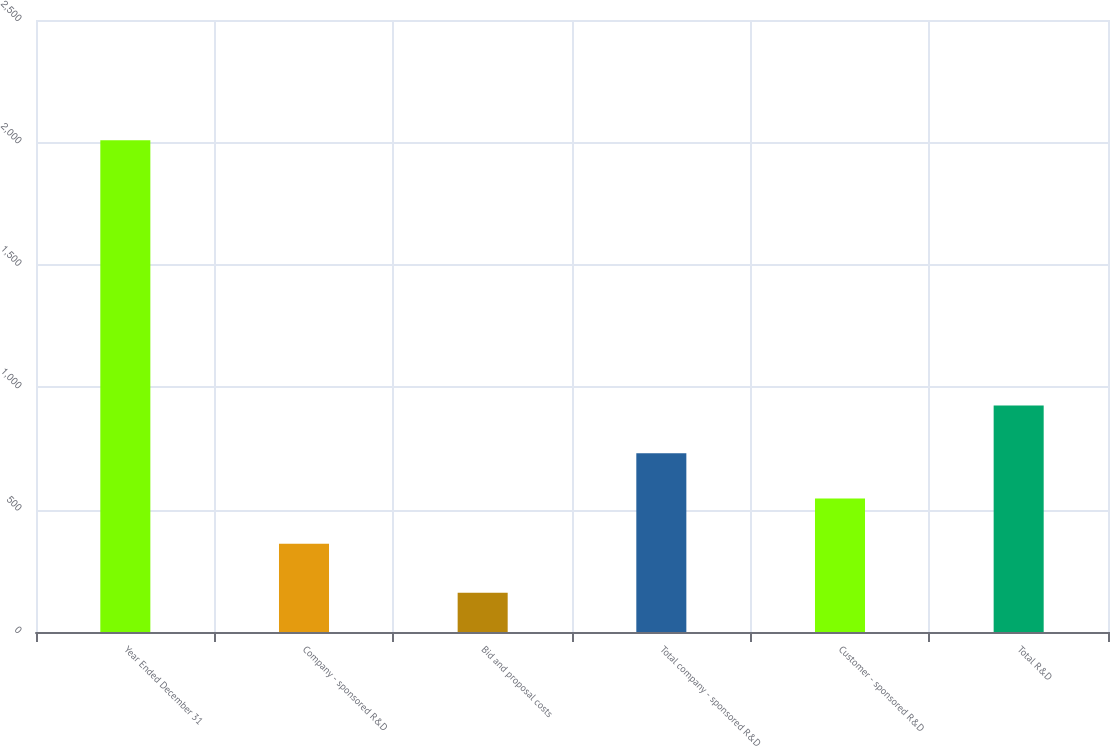Convert chart. <chart><loc_0><loc_0><loc_500><loc_500><bar_chart><fcel>Year Ended December 31<fcel>Company - sponsored R&D<fcel>Bid and proposal costs<fcel>Total company - sponsored R&D<fcel>Customer - sponsored R&D<fcel>Total R&D<nl><fcel>2009<fcel>360<fcel>160<fcel>729.8<fcel>544.9<fcel>925<nl></chart> 